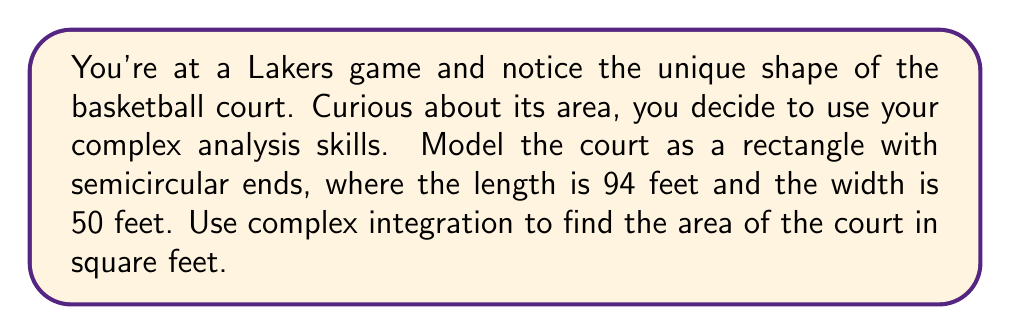Can you solve this math problem? Let's approach this step-by-step using complex integration:

1) First, we need to parametrize the boundary of the court. We can do this by defining a complex function $z(t)$ that traces the boundary:

   $$z(t) = \begin{cases}
   25e^{it} + 47 & \text{for } 0 \leq t \leq \pi \\
   47 - 25i & \text{for } \pi \leq t \leq \pi + 1 \\
   -25e^{it} - 47 & \text{for } \pi + 1 \leq t \leq 2\pi + 1 \\
   -47 + 25i & \text{for } 2\pi + 1 \leq t \leq 2\pi + 2
   \end{cases}$$

2) The area enclosed by a simple closed curve $C$ can be computed using the complex integral:

   $$A = -\frac{1}{2i} \oint_C z\,d\bar{z}$$

3) We need to evaluate this integral for each part of our parametrization:

   For $0 \leq t \leq \pi$:
   $$\int_0^\pi (25e^{it} + 47)(25ie^{it})\,dt = \frac{25^2\pi}{2} + 47 \cdot 25 \cdot 2i$$

   For $\pi \leq t \leq \pi + 1$:
   $$(47 - 25i)(50)\,dt = 2350 + 1250i$$

   For $\pi + 1 \leq t \leq 2\pi + 1$:
   $$\int_\pi^{2\pi} (-25e^{it} - 47)(25ie^{it})\,dt = \frac{25^2\pi}{2} - 47 \cdot 25 \cdot 2i$$

   For $2\pi + 1 \leq t \leq 2\pi + 2$:
   $$(-47 + 25i)(50)\,dt = -2350 - 1250i$$

4) Sum all parts:
   $$25^2\pi + 2350 + 1250i + 25^2\pi - 2350 - 1250i = 50^2\pi$$

5) Apply the area formula:
   $$A = -\frac{1}{2i}(50^2\pi) = 1250\pi$$

Therefore, the area of the basketball court is $1250\pi$ square feet.
Answer: $1250\pi$ square feet 